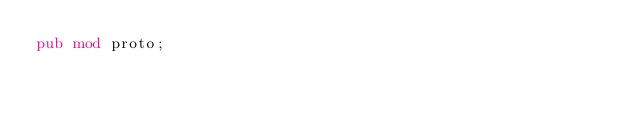<code> <loc_0><loc_0><loc_500><loc_500><_Rust_>pub mod proto;
</code> 